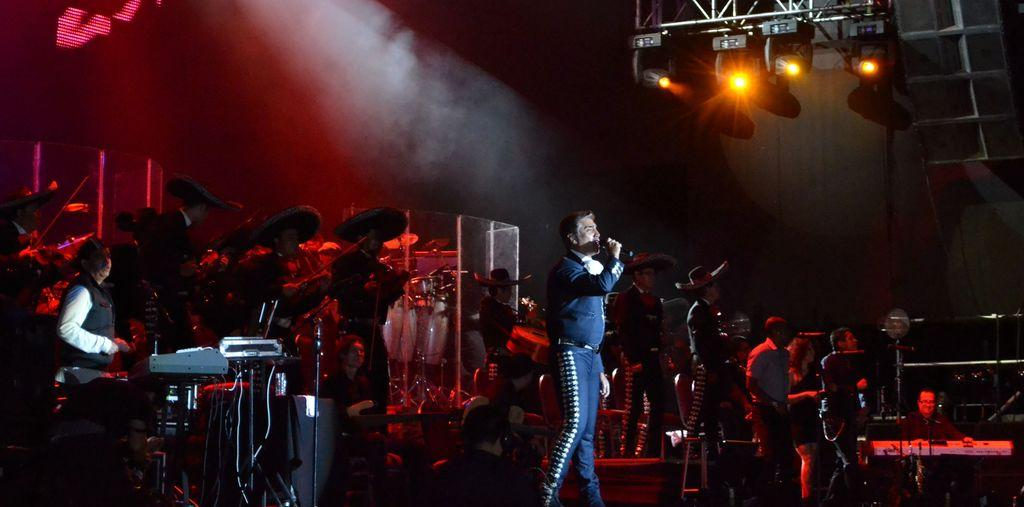What is the person in the image doing? The person is standing and holding a microphone. What are the other people in the image doing? The other people are standing and holding musical instruments. What can be seen in the image that is related to lighting? There are focus lights and lighting trusses in the image. What type of icicle can be seen hanging from the lighting trusses in the image? There are no icicles present in the image; it is indoors and does not show any frozen precipitation. 